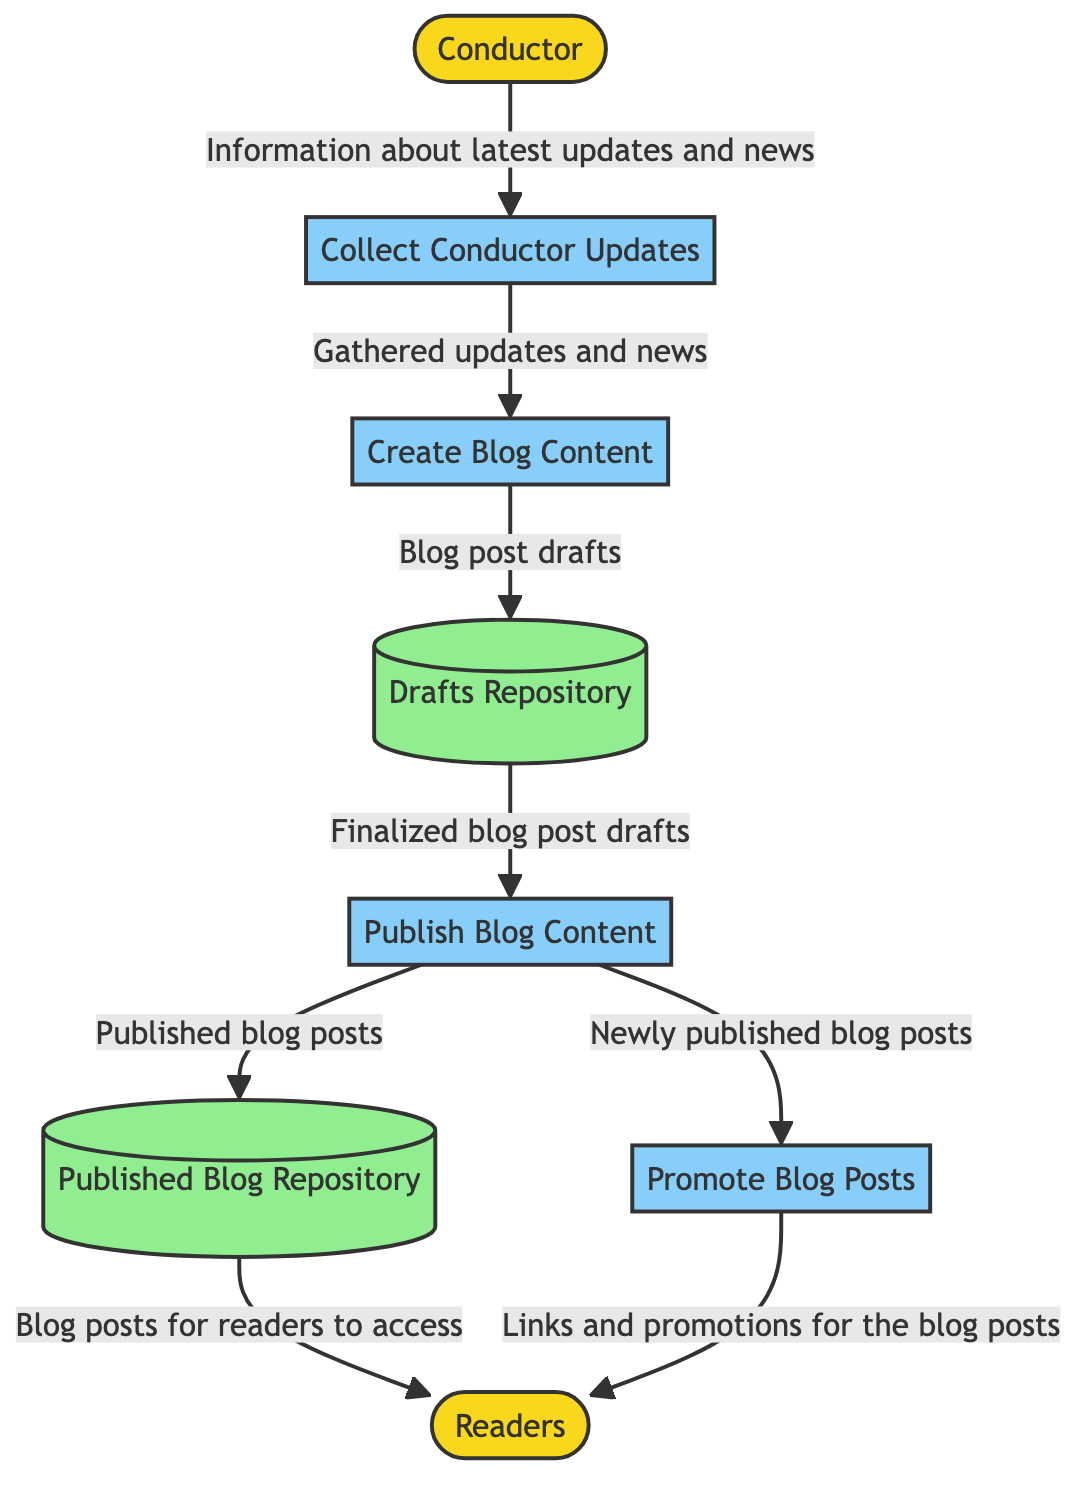What is the first process in the diagram? The first process is indicated by the starting flow from the Conductor to the process labeled "Collect Conductor Updates." This can be determined by looking at the arrows pointing towards the processes.
Answer: Collect Conductor Updates How many external entities are represented in the diagram? There are two external entities shown: the Conductor and the Readers. The count can be found by identifying the nodes designated as external entities in the diagram.
Answer: 2 Which data store receives inputs directly from the "Publish Blog Content" process? The "Published Blog Repository" is the data store that receives outputs directly from the "Publish Blog Content" process as indicated by the arrows pointing from the process to the data store.
Answer: Published Blog Repository What type of information flows from "Collect Conductor Updates" to "Create Blog Content"? The type of information flowing between these two processes is described as "Gathered updates and news," which explains what is being transferred from one process to the next in the flow.
Answer: Gathered updates and news What is the last step before blog posts reach the Readers? The final step before the Readers receive the blog posts is through the "Promote Blog Posts" process, which shares the links and promotions, as evidenced by the arrows leading from the process to the external entity.
Answer: Promote Blog Posts How many processes are there in total in the diagram? There are four processes listed in the diagram: "Collect Conductor Updates," "Create Blog Content," "Publish Blog Content," and "Promote Blog Posts." This can be confirmed by counting the process nodes.
Answer: 4 Which entity is responsible for providing information to the "Collect Conductor Updates" process? The entity providing information to the "Collect Conductor Updates" process is the Conductor. This is clear from the flow arrow leading into the process from the external entity.
Answer: Conductor What is the relationship between the "Publish Blog Content" process and the "Promote Blog Posts" process? The relationship is that "Publish Blog Content" provides newly published blog posts as input to "Promote Blog Posts," establishing a sequential flow of information between these two processes.
Answer: Newly published blog posts 